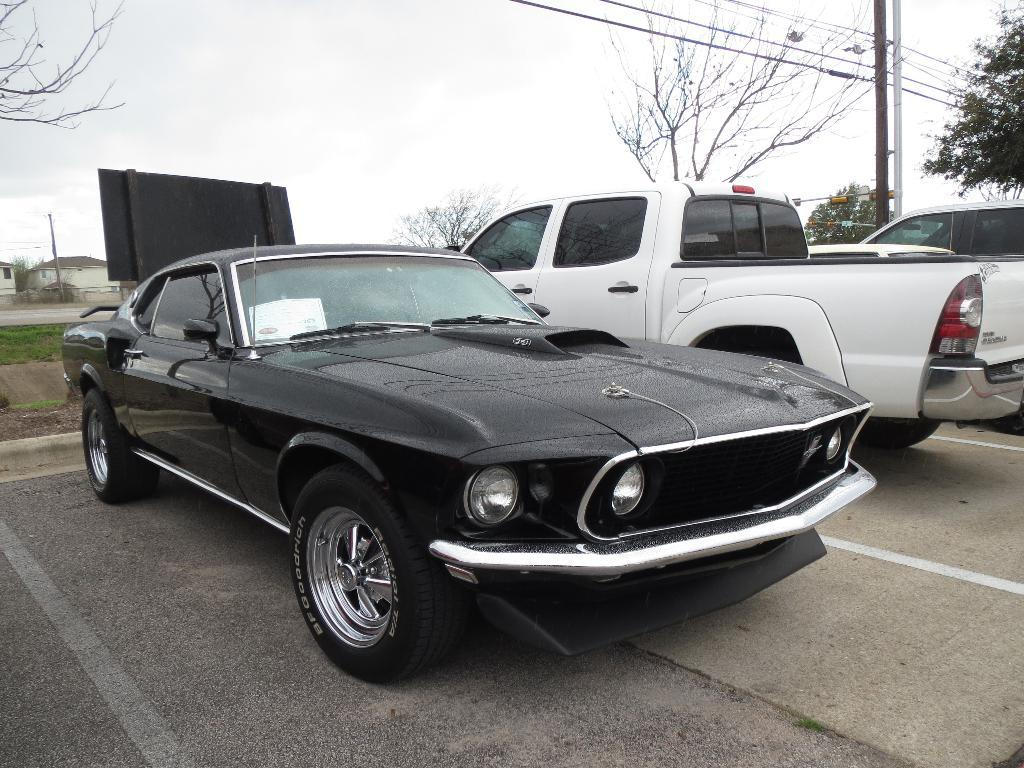What can be seen on the road in the image? There are cars parked on the road in the image. What type of vegetation is visible in the image? There are trees visible in the image. What structures can be seen in the image? There are poles, houses with roofs, and a fence in the image. What else is present in the image? There are wires in the image. What is the condition of the sky in the image? The sky is visible in the image, and it appears cloudy. Where is the secretary sitting in the image? There is no secretary present in the image. What is the current temperature in the image? The image does not provide information about the temperature. 